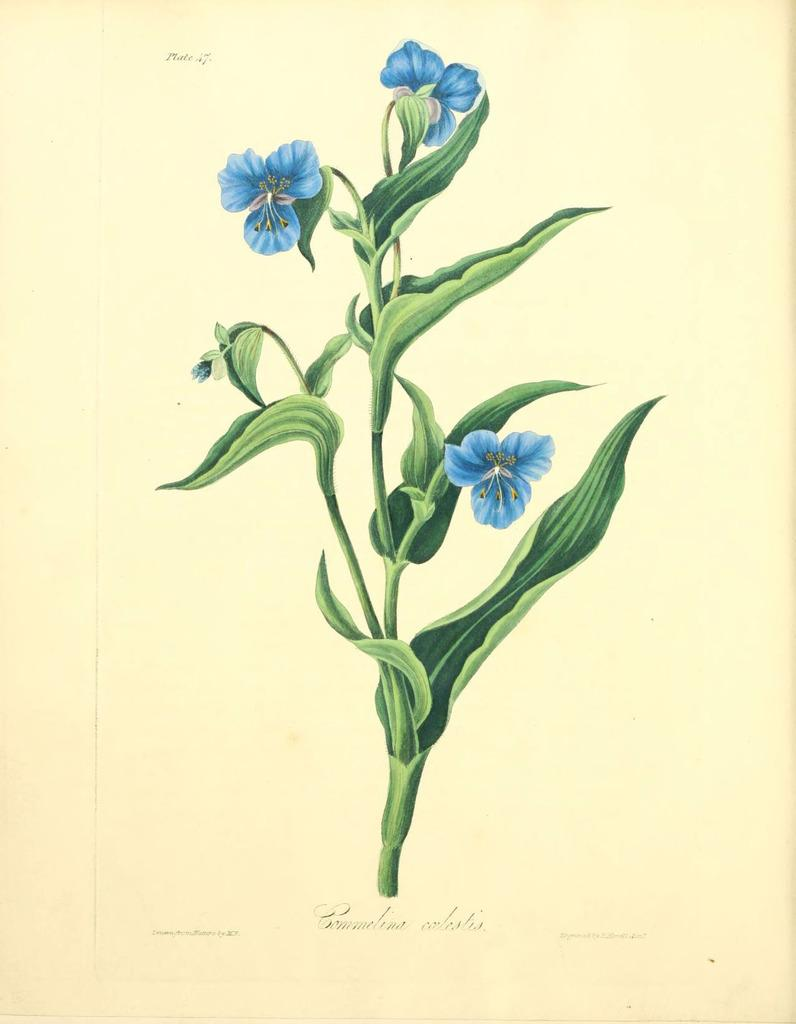What is the main subject of the painting in the image? The painting in the image depicts flowers. What color are the flowers in the painting? The flowers are blue in color. What else can be seen in the painting besides the flowers? There are flower stems and leaves visible in the painting. Is there any text present in the painting? Yes, there is text in the painting. What type of parent is depicted in the painting? There is no parent depicted in the painting; it features flowers, flower stems, leaves, and text. Is there a lawyer present in the painting? There is no lawyer depicted in the painting; it features flowers, flower stems, leaves, and text. 